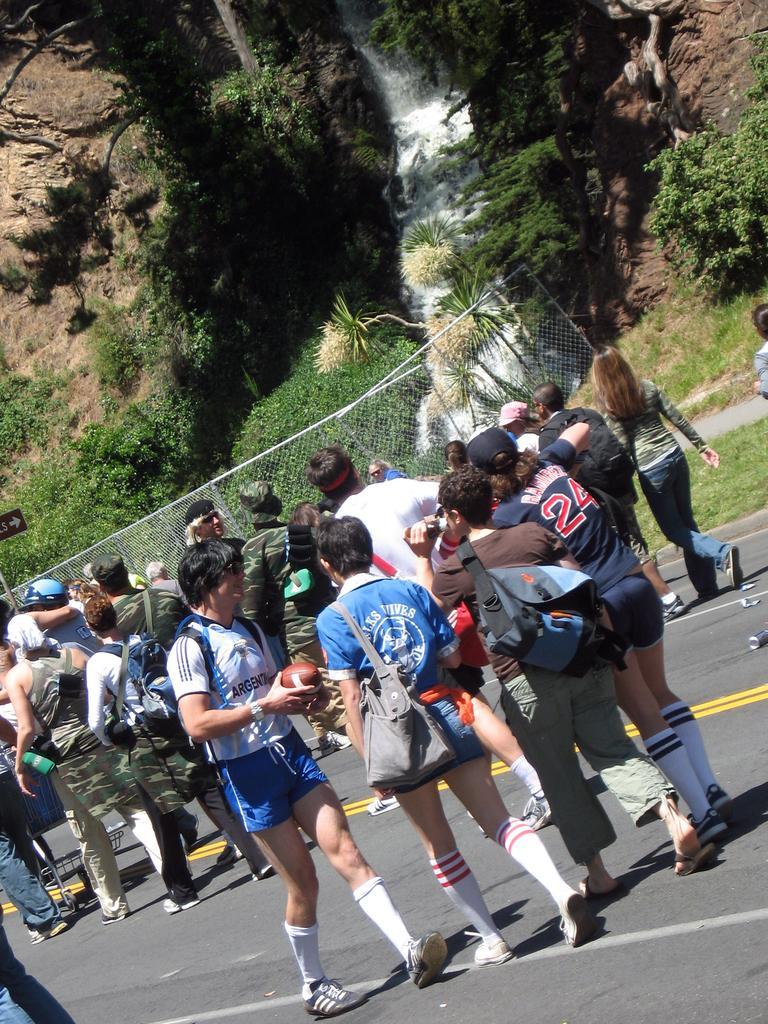Can you describe this image briefly? In the center of the image we can see a group of people are walking on the road and wearing the bags and some of them are wearing hats and a boy is holding a ball. At the bottom of the image we can see the road and trolley. In the background of the image we can see the mesh, trees, waterfall, rocks, sign board and grass. 